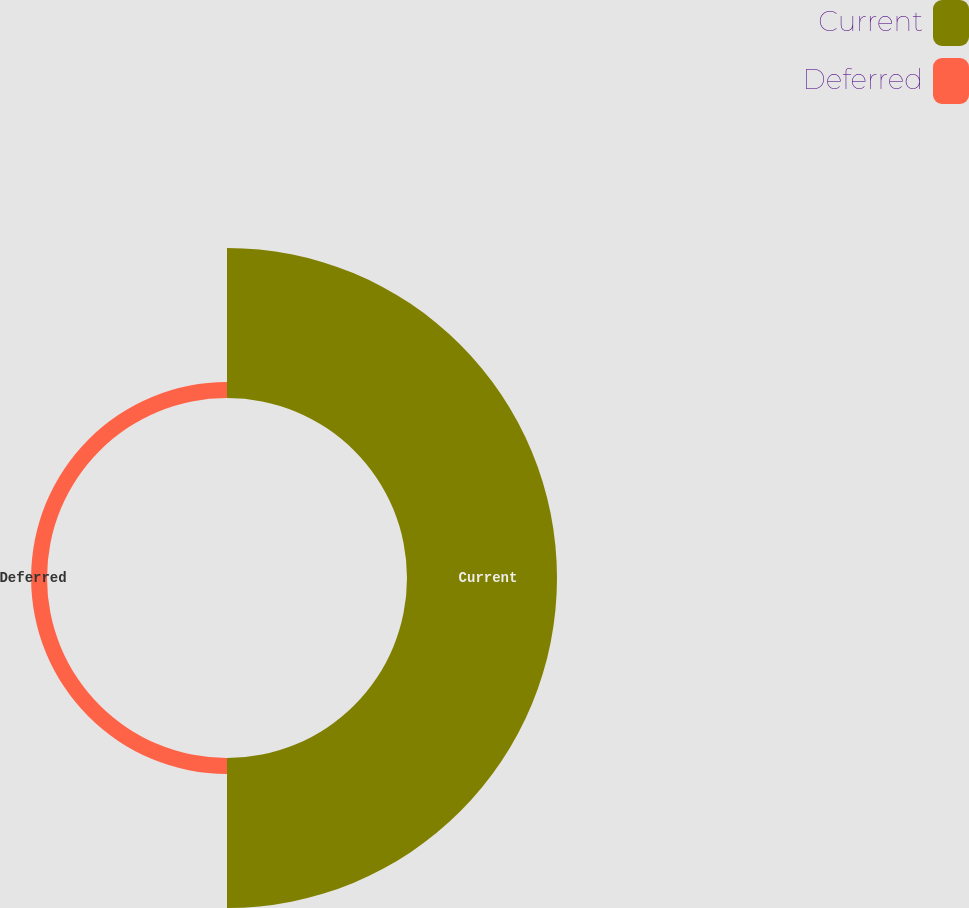Convert chart. <chart><loc_0><loc_0><loc_500><loc_500><pie_chart><fcel>Current<fcel>Deferred<nl><fcel>90.42%<fcel>9.58%<nl></chart> 